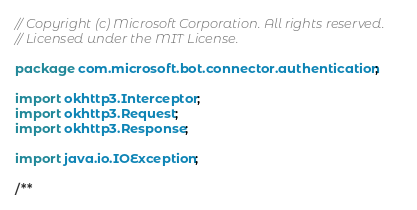<code> <loc_0><loc_0><loc_500><loc_500><_Java_>// Copyright (c) Microsoft Corporation. All rights reserved.
// Licensed under the MIT License.

package com.microsoft.bot.connector.authentication;

import okhttp3.Interceptor;
import okhttp3.Request;
import okhttp3.Response;

import java.io.IOException;

/**</code> 